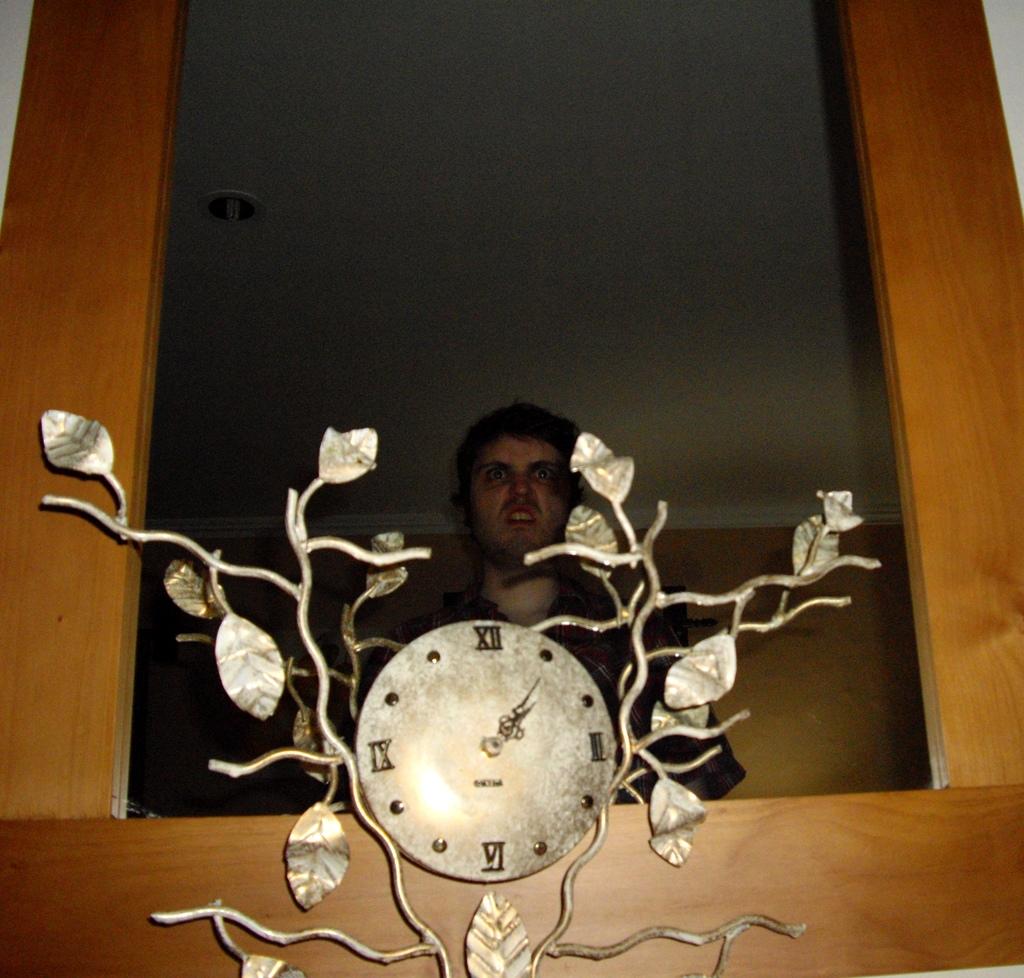What time is it?
Offer a terse response. 1:05. 